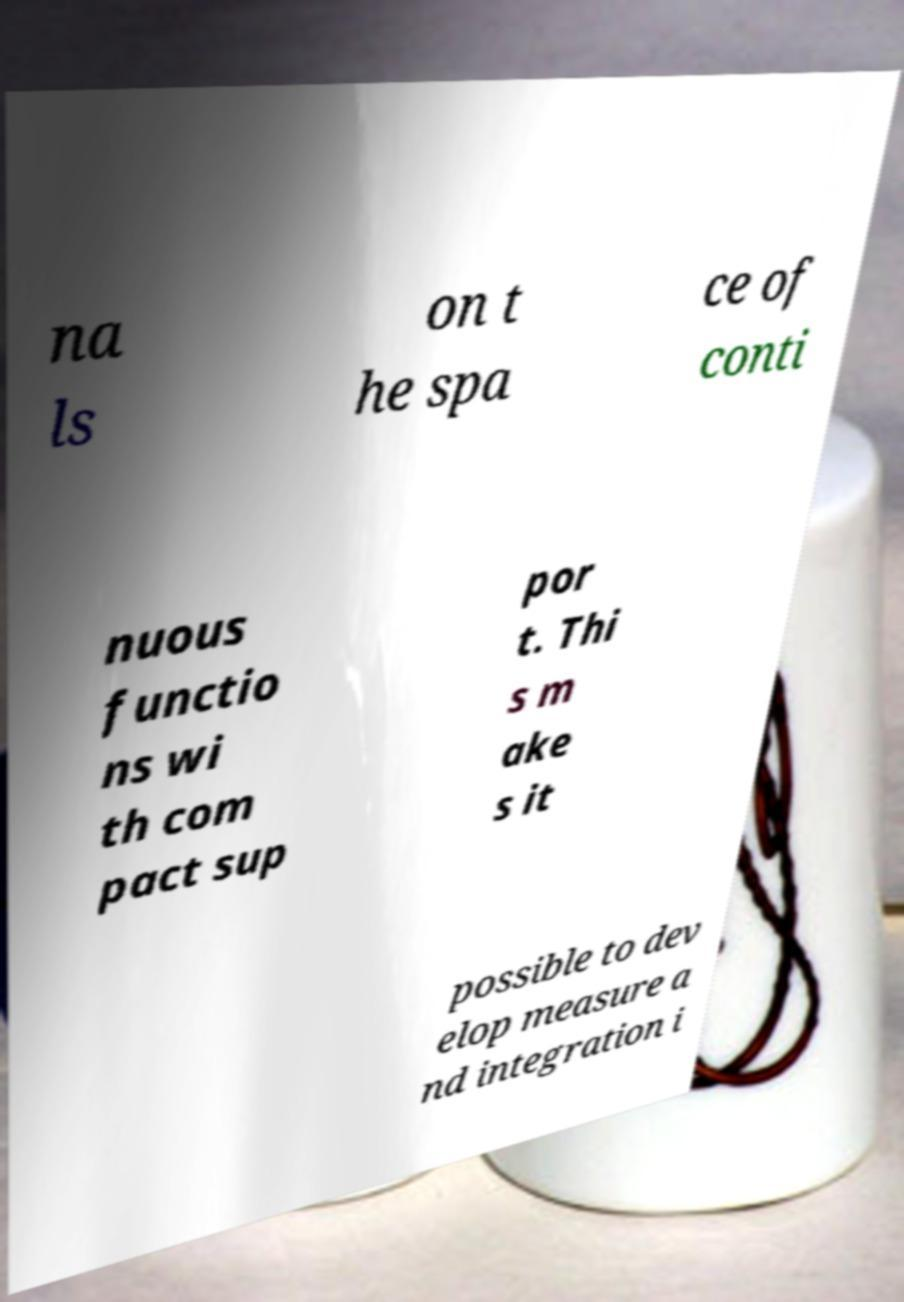Can you accurately transcribe the text from the provided image for me? na ls on t he spa ce of conti nuous functio ns wi th com pact sup por t. Thi s m ake s it possible to dev elop measure a nd integration i 